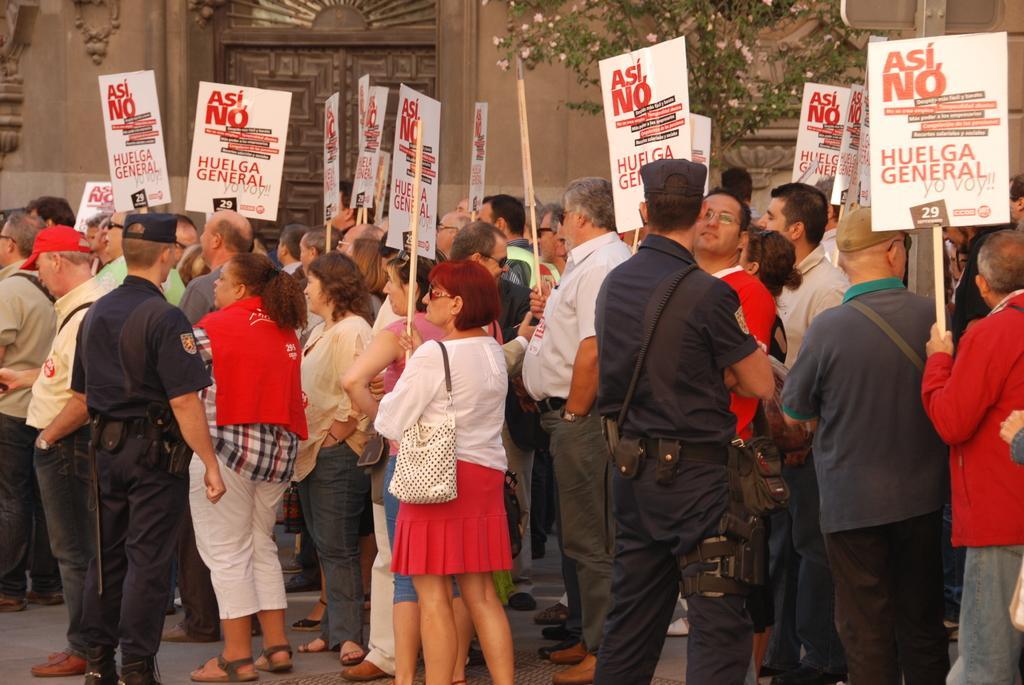Can you describe this image briefly? In this image I can see group of people standing and holding few boards and the boards are in white color. Background I can see few trees in green color and I can also see the building in brown color. 